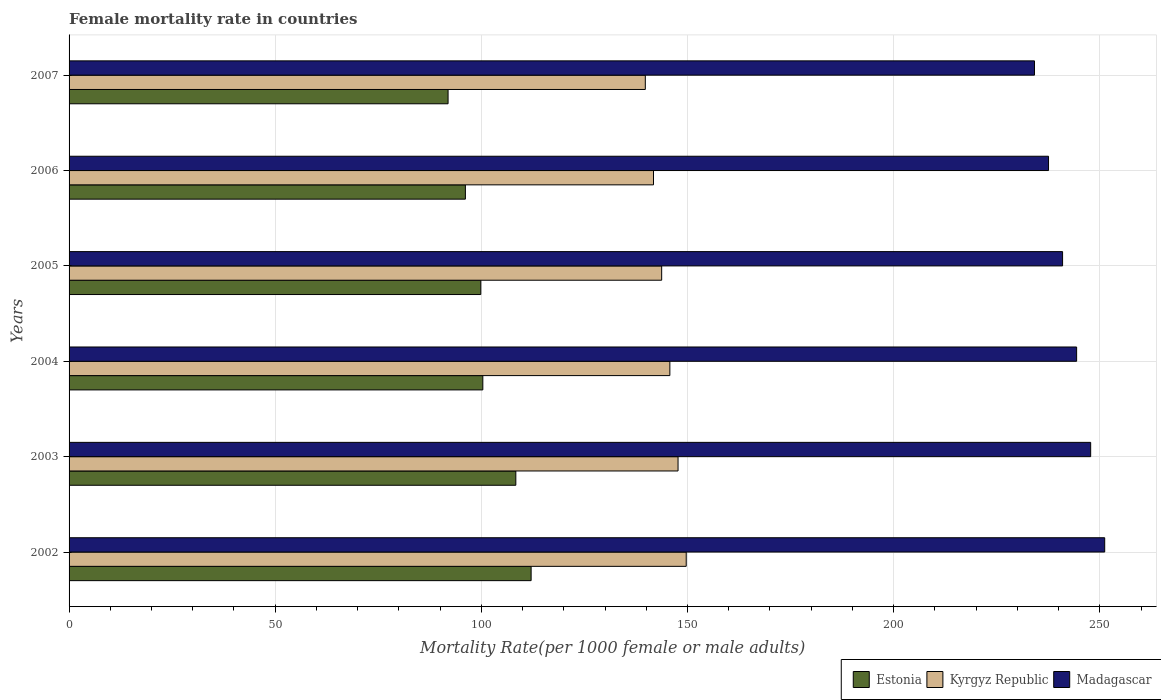Are the number of bars on each tick of the Y-axis equal?
Give a very brief answer. Yes. How many bars are there on the 5th tick from the bottom?
Offer a terse response. 3. What is the label of the 3rd group of bars from the top?
Your answer should be very brief. 2005. In how many cases, is the number of bars for a given year not equal to the number of legend labels?
Offer a terse response. 0. What is the female mortality rate in Kyrgyz Republic in 2005?
Give a very brief answer. 143.73. Across all years, what is the maximum female mortality rate in Estonia?
Offer a terse response. 112.07. Across all years, what is the minimum female mortality rate in Madagascar?
Make the answer very short. 234.15. In which year was the female mortality rate in Madagascar maximum?
Provide a succinct answer. 2002. What is the total female mortality rate in Estonia in the graph?
Keep it short and to the point. 608.68. What is the difference between the female mortality rate in Madagascar in 2002 and that in 2006?
Give a very brief answer. 13.63. What is the difference between the female mortality rate in Estonia in 2005 and the female mortality rate in Kyrgyz Republic in 2003?
Offer a terse response. -47.84. What is the average female mortality rate in Estonia per year?
Offer a very short reply. 101.45. In the year 2002, what is the difference between the female mortality rate in Estonia and female mortality rate in Kyrgyz Republic?
Your answer should be compact. -37.62. What is the ratio of the female mortality rate in Madagascar in 2002 to that in 2006?
Provide a succinct answer. 1.06. Is the female mortality rate in Madagascar in 2003 less than that in 2004?
Provide a short and direct response. No. What is the difference between the highest and the second highest female mortality rate in Estonia?
Provide a short and direct response. 3.71. What is the difference between the highest and the lowest female mortality rate in Kyrgyz Republic?
Your answer should be very brief. 9.92. Is the sum of the female mortality rate in Kyrgyz Republic in 2002 and 2007 greater than the maximum female mortality rate in Estonia across all years?
Provide a succinct answer. Yes. What does the 3rd bar from the top in 2002 represents?
Your answer should be compact. Estonia. What does the 3rd bar from the bottom in 2006 represents?
Give a very brief answer. Madagascar. Is it the case that in every year, the sum of the female mortality rate in Kyrgyz Republic and female mortality rate in Estonia is greater than the female mortality rate in Madagascar?
Provide a short and direct response. No. How many bars are there?
Give a very brief answer. 18. Are the values on the major ticks of X-axis written in scientific E-notation?
Provide a short and direct response. No. Does the graph contain any zero values?
Your answer should be compact. No. Does the graph contain grids?
Your answer should be compact. Yes. How are the legend labels stacked?
Provide a short and direct response. Horizontal. What is the title of the graph?
Offer a terse response. Female mortality rate in countries. Does "Albania" appear as one of the legend labels in the graph?
Your response must be concise. No. What is the label or title of the X-axis?
Provide a succinct answer. Mortality Rate(per 1000 female or male adults). What is the Mortality Rate(per 1000 female or male adults) of Estonia in 2002?
Offer a very short reply. 112.07. What is the Mortality Rate(per 1000 female or male adults) of Kyrgyz Republic in 2002?
Your response must be concise. 149.68. What is the Mortality Rate(per 1000 female or male adults) in Madagascar in 2002?
Your response must be concise. 251.18. What is the Mortality Rate(per 1000 female or male adults) in Estonia in 2003?
Provide a succinct answer. 108.36. What is the Mortality Rate(per 1000 female or male adults) of Kyrgyz Republic in 2003?
Provide a succinct answer. 147.7. What is the Mortality Rate(per 1000 female or male adults) of Madagascar in 2003?
Provide a succinct answer. 247.78. What is the Mortality Rate(per 1000 female or male adults) of Estonia in 2004?
Your answer should be compact. 100.35. What is the Mortality Rate(per 1000 female or male adults) in Kyrgyz Republic in 2004?
Provide a succinct answer. 145.72. What is the Mortality Rate(per 1000 female or male adults) of Madagascar in 2004?
Provide a succinct answer. 244.37. What is the Mortality Rate(per 1000 female or male adults) in Estonia in 2005?
Your answer should be very brief. 99.86. What is the Mortality Rate(per 1000 female or male adults) of Kyrgyz Republic in 2005?
Ensure brevity in your answer.  143.73. What is the Mortality Rate(per 1000 female or male adults) of Madagascar in 2005?
Make the answer very short. 240.96. What is the Mortality Rate(per 1000 female or male adults) in Estonia in 2006?
Give a very brief answer. 96.12. What is the Mortality Rate(per 1000 female or male adults) of Kyrgyz Republic in 2006?
Your response must be concise. 141.75. What is the Mortality Rate(per 1000 female or male adults) of Madagascar in 2006?
Keep it short and to the point. 237.56. What is the Mortality Rate(per 1000 female or male adults) in Estonia in 2007?
Provide a succinct answer. 91.93. What is the Mortality Rate(per 1000 female or male adults) in Kyrgyz Republic in 2007?
Make the answer very short. 139.76. What is the Mortality Rate(per 1000 female or male adults) of Madagascar in 2007?
Your response must be concise. 234.15. Across all years, what is the maximum Mortality Rate(per 1000 female or male adults) of Estonia?
Provide a succinct answer. 112.07. Across all years, what is the maximum Mortality Rate(per 1000 female or male adults) of Kyrgyz Republic?
Ensure brevity in your answer.  149.68. Across all years, what is the maximum Mortality Rate(per 1000 female or male adults) in Madagascar?
Offer a terse response. 251.18. Across all years, what is the minimum Mortality Rate(per 1000 female or male adults) in Estonia?
Provide a short and direct response. 91.93. Across all years, what is the minimum Mortality Rate(per 1000 female or male adults) in Kyrgyz Republic?
Ensure brevity in your answer.  139.76. Across all years, what is the minimum Mortality Rate(per 1000 female or male adults) of Madagascar?
Offer a terse response. 234.15. What is the total Mortality Rate(per 1000 female or male adults) in Estonia in the graph?
Ensure brevity in your answer.  608.68. What is the total Mortality Rate(per 1000 female or male adults) in Kyrgyz Republic in the graph?
Provide a succinct answer. 868.34. What is the total Mortality Rate(per 1000 female or male adults) of Madagascar in the graph?
Your response must be concise. 1456.01. What is the difference between the Mortality Rate(per 1000 female or male adults) of Estonia in 2002 and that in 2003?
Make the answer very short. 3.71. What is the difference between the Mortality Rate(per 1000 female or male adults) in Kyrgyz Republic in 2002 and that in 2003?
Ensure brevity in your answer.  1.98. What is the difference between the Mortality Rate(per 1000 female or male adults) of Madagascar in 2002 and that in 2003?
Offer a terse response. 3.41. What is the difference between the Mortality Rate(per 1000 female or male adults) in Estonia in 2002 and that in 2004?
Offer a very short reply. 11.71. What is the difference between the Mortality Rate(per 1000 female or male adults) in Kyrgyz Republic in 2002 and that in 2004?
Keep it short and to the point. 3.97. What is the difference between the Mortality Rate(per 1000 female or male adults) of Madagascar in 2002 and that in 2004?
Offer a terse response. 6.81. What is the difference between the Mortality Rate(per 1000 female or male adults) of Estonia in 2002 and that in 2005?
Your answer should be compact. 12.21. What is the difference between the Mortality Rate(per 1000 female or male adults) in Kyrgyz Republic in 2002 and that in 2005?
Your answer should be compact. 5.95. What is the difference between the Mortality Rate(per 1000 female or male adults) of Madagascar in 2002 and that in 2005?
Offer a very short reply. 10.22. What is the difference between the Mortality Rate(per 1000 female or male adults) of Estonia in 2002 and that in 2006?
Ensure brevity in your answer.  15.95. What is the difference between the Mortality Rate(per 1000 female or male adults) in Kyrgyz Republic in 2002 and that in 2006?
Your answer should be compact. 7.94. What is the difference between the Mortality Rate(per 1000 female or male adults) in Madagascar in 2002 and that in 2006?
Your response must be concise. 13.63. What is the difference between the Mortality Rate(per 1000 female or male adults) of Estonia in 2002 and that in 2007?
Offer a terse response. 20.14. What is the difference between the Mortality Rate(per 1000 female or male adults) in Kyrgyz Republic in 2002 and that in 2007?
Ensure brevity in your answer.  9.92. What is the difference between the Mortality Rate(per 1000 female or male adults) in Madagascar in 2002 and that in 2007?
Your answer should be very brief. 17.03. What is the difference between the Mortality Rate(per 1000 female or male adults) in Estonia in 2003 and that in 2004?
Provide a succinct answer. 8. What is the difference between the Mortality Rate(per 1000 female or male adults) in Kyrgyz Republic in 2003 and that in 2004?
Make the answer very short. 1.98. What is the difference between the Mortality Rate(per 1000 female or male adults) of Madagascar in 2003 and that in 2004?
Ensure brevity in your answer.  3.41. What is the difference between the Mortality Rate(per 1000 female or male adults) of Estonia in 2003 and that in 2005?
Make the answer very short. 8.49. What is the difference between the Mortality Rate(per 1000 female or male adults) in Kyrgyz Republic in 2003 and that in 2005?
Your answer should be compact. 3.97. What is the difference between the Mortality Rate(per 1000 female or male adults) of Madagascar in 2003 and that in 2005?
Your answer should be very brief. 6.81. What is the difference between the Mortality Rate(per 1000 female or male adults) in Estonia in 2003 and that in 2006?
Make the answer very short. 12.23. What is the difference between the Mortality Rate(per 1000 female or male adults) in Kyrgyz Republic in 2003 and that in 2006?
Offer a terse response. 5.95. What is the difference between the Mortality Rate(per 1000 female or male adults) of Madagascar in 2003 and that in 2006?
Offer a very short reply. 10.22. What is the difference between the Mortality Rate(per 1000 female or male adults) of Estonia in 2003 and that in 2007?
Your answer should be very brief. 16.43. What is the difference between the Mortality Rate(per 1000 female or male adults) in Kyrgyz Republic in 2003 and that in 2007?
Keep it short and to the point. 7.94. What is the difference between the Mortality Rate(per 1000 female or male adults) of Madagascar in 2003 and that in 2007?
Keep it short and to the point. 13.63. What is the difference between the Mortality Rate(per 1000 female or male adults) in Estonia in 2004 and that in 2005?
Keep it short and to the point. 0.49. What is the difference between the Mortality Rate(per 1000 female or male adults) in Kyrgyz Republic in 2004 and that in 2005?
Your answer should be compact. 1.98. What is the difference between the Mortality Rate(per 1000 female or male adults) of Madagascar in 2004 and that in 2005?
Offer a terse response. 3.41. What is the difference between the Mortality Rate(per 1000 female or male adults) of Estonia in 2004 and that in 2006?
Make the answer very short. 4.23. What is the difference between the Mortality Rate(per 1000 female or male adults) in Kyrgyz Republic in 2004 and that in 2006?
Make the answer very short. 3.97. What is the difference between the Mortality Rate(per 1000 female or male adults) in Madagascar in 2004 and that in 2006?
Keep it short and to the point. 6.81. What is the difference between the Mortality Rate(per 1000 female or male adults) in Estonia in 2004 and that in 2007?
Your answer should be very brief. 8.43. What is the difference between the Mortality Rate(per 1000 female or male adults) in Kyrgyz Republic in 2004 and that in 2007?
Make the answer very short. 5.95. What is the difference between the Mortality Rate(per 1000 female or male adults) in Madagascar in 2004 and that in 2007?
Provide a short and direct response. 10.22. What is the difference between the Mortality Rate(per 1000 female or male adults) in Estonia in 2005 and that in 2006?
Offer a terse response. 3.74. What is the difference between the Mortality Rate(per 1000 female or male adults) of Kyrgyz Republic in 2005 and that in 2006?
Offer a very short reply. 1.98. What is the difference between the Mortality Rate(per 1000 female or male adults) of Madagascar in 2005 and that in 2006?
Provide a short and direct response. 3.41. What is the difference between the Mortality Rate(per 1000 female or male adults) of Estonia in 2005 and that in 2007?
Give a very brief answer. 7.93. What is the difference between the Mortality Rate(per 1000 female or male adults) of Kyrgyz Republic in 2005 and that in 2007?
Your answer should be very brief. 3.97. What is the difference between the Mortality Rate(per 1000 female or male adults) of Madagascar in 2005 and that in 2007?
Provide a succinct answer. 6.81. What is the difference between the Mortality Rate(per 1000 female or male adults) in Estonia in 2006 and that in 2007?
Make the answer very short. 4.2. What is the difference between the Mortality Rate(per 1000 female or male adults) of Kyrgyz Republic in 2006 and that in 2007?
Your response must be concise. 1.98. What is the difference between the Mortality Rate(per 1000 female or male adults) in Madagascar in 2006 and that in 2007?
Ensure brevity in your answer.  3.41. What is the difference between the Mortality Rate(per 1000 female or male adults) of Estonia in 2002 and the Mortality Rate(per 1000 female or male adults) of Kyrgyz Republic in 2003?
Ensure brevity in your answer.  -35.63. What is the difference between the Mortality Rate(per 1000 female or male adults) in Estonia in 2002 and the Mortality Rate(per 1000 female or male adults) in Madagascar in 2003?
Ensure brevity in your answer.  -135.71. What is the difference between the Mortality Rate(per 1000 female or male adults) of Kyrgyz Republic in 2002 and the Mortality Rate(per 1000 female or male adults) of Madagascar in 2003?
Keep it short and to the point. -98.09. What is the difference between the Mortality Rate(per 1000 female or male adults) in Estonia in 2002 and the Mortality Rate(per 1000 female or male adults) in Kyrgyz Republic in 2004?
Your answer should be compact. -33.65. What is the difference between the Mortality Rate(per 1000 female or male adults) in Estonia in 2002 and the Mortality Rate(per 1000 female or male adults) in Madagascar in 2004?
Make the answer very short. -132.3. What is the difference between the Mortality Rate(per 1000 female or male adults) in Kyrgyz Republic in 2002 and the Mortality Rate(per 1000 female or male adults) in Madagascar in 2004?
Provide a succinct answer. -94.69. What is the difference between the Mortality Rate(per 1000 female or male adults) in Estonia in 2002 and the Mortality Rate(per 1000 female or male adults) in Kyrgyz Republic in 2005?
Your answer should be compact. -31.66. What is the difference between the Mortality Rate(per 1000 female or male adults) of Estonia in 2002 and the Mortality Rate(per 1000 female or male adults) of Madagascar in 2005?
Provide a succinct answer. -128.9. What is the difference between the Mortality Rate(per 1000 female or male adults) in Kyrgyz Republic in 2002 and the Mortality Rate(per 1000 female or male adults) in Madagascar in 2005?
Make the answer very short. -91.28. What is the difference between the Mortality Rate(per 1000 female or male adults) in Estonia in 2002 and the Mortality Rate(per 1000 female or male adults) in Kyrgyz Republic in 2006?
Offer a terse response. -29.68. What is the difference between the Mortality Rate(per 1000 female or male adults) of Estonia in 2002 and the Mortality Rate(per 1000 female or male adults) of Madagascar in 2006?
Your response must be concise. -125.49. What is the difference between the Mortality Rate(per 1000 female or male adults) in Kyrgyz Republic in 2002 and the Mortality Rate(per 1000 female or male adults) in Madagascar in 2006?
Make the answer very short. -87.87. What is the difference between the Mortality Rate(per 1000 female or male adults) of Estonia in 2002 and the Mortality Rate(per 1000 female or male adults) of Kyrgyz Republic in 2007?
Offer a terse response. -27.7. What is the difference between the Mortality Rate(per 1000 female or male adults) in Estonia in 2002 and the Mortality Rate(per 1000 female or male adults) in Madagascar in 2007?
Give a very brief answer. -122.08. What is the difference between the Mortality Rate(per 1000 female or male adults) of Kyrgyz Republic in 2002 and the Mortality Rate(per 1000 female or male adults) of Madagascar in 2007?
Keep it short and to the point. -84.47. What is the difference between the Mortality Rate(per 1000 female or male adults) of Estonia in 2003 and the Mortality Rate(per 1000 female or male adults) of Kyrgyz Republic in 2004?
Offer a terse response. -37.36. What is the difference between the Mortality Rate(per 1000 female or male adults) of Estonia in 2003 and the Mortality Rate(per 1000 female or male adults) of Madagascar in 2004?
Your answer should be compact. -136.02. What is the difference between the Mortality Rate(per 1000 female or male adults) in Kyrgyz Republic in 2003 and the Mortality Rate(per 1000 female or male adults) in Madagascar in 2004?
Make the answer very short. -96.67. What is the difference between the Mortality Rate(per 1000 female or male adults) of Estonia in 2003 and the Mortality Rate(per 1000 female or male adults) of Kyrgyz Republic in 2005?
Provide a short and direct response. -35.38. What is the difference between the Mortality Rate(per 1000 female or male adults) in Estonia in 2003 and the Mortality Rate(per 1000 female or male adults) in Madagascar in 2005?
Your response must be concise. -132.61. What is the difference between the Mortality Rate(per 1000 female or male adults) in Kyrgyz Republic in 2003 and the Mortality Rate(per 1000 female or male adults) in Madagascar in 2005?
Offer a very short reply. -93.26. What is the difference between the Mortality Rate(per 1000 female or male adults) of Estonia in 2003 and the Mortality Rate(per 1000 female or male adults) of Kyrgyz Republic in 2006?
Your answer should be very brief. -33.39. What is the difference between the Mortality Rate(per 1000 female or male adults) in Estonia in 2003 and the Mortality Rate(per 1000 female or male adults) in Madagascar in 2006?
Your answer should be very brief. -129.2. What is the difference between the Mortality Rate(per 1000 female or male adults) in Kyrgyz Republic in 2003 and the Mortality Rate(per 1000 female or male adults) in Madagascar in 2006?
Give a very brief answer. -89.86. What is the difference between the Mortality Rate(per 1000 female or male adults) in Estonia in 2003 and the Mortality Rate(per 1000 female or male adults) in Kyrgyz Republic in 2007?
Your answer should be very brief. -31.41. What is the difference between the Mortality Rate(per 1000 female or male adults) of Estonia in 2003 and the Mortality Rate(per 1000 female or male adults) of Madagascar in 2007?
Your answer should be compact. -125.8. What is the difference between the Mortality Rate(per 1000 female or male adults) in Kyrgyz Republic in 2003 and the Mortality Rate(per 1000 female or male adults) in Madagascar in 2007?
Give a very brief answer. -86.45. What is the difference between the Mortality Rate(per 1000 female or male adults) of Estonia in 2004 and the Mortality Rate(per 1000 female or male adults) of Kyrgyz Republic in 2005?
Give a very brief answer. -43.38. What is the difference between the Mortality Rate(per 1000 female or male adults) of Estonia in 2004 and the Mortality Rate(per 1000 female or male adults) of Madagascar in 2005?
Your answer should be very brief. -140.61. What is the difference between the Mortality Rate(per 1000 female or male adults) of Kyrgyz Republic in 2004 and the Mortality Rate(per 1000 female or male adults) of Madagascar in 2005?
Provide a short and direct response. -95.25. What is the difference between the Mortality Rate(per 1000 female or male adults) of Estonia in 2004 and the Mortality Rate(per 1000 female or male adults) of Kyrgyz Republic in 2006?
Make the answer very short. -41.39. What is the difference between the Mortality Rate(per 1000 female or male adults) in Estonia in 2004 and the Mortality Rate(per 1000 female or male adults) in Madagascar in 2006?
Provide a short and direct response. -137.21. What is the difference between the Mortality Rate(per 1000 female or male adults) in Kyrgyz Republic in 2004 and the Mortality Rate(per 1000 female or male adults) in Madagascar in 2006?
Your answer should be very brief. -91.84. What is the difference between the Mortality Rate(per 1000 female or male adults) of Estonia in 2004 and the Mortality Rate(per 1000 female or male adults) of Kyrgyz Republic in 2007?
Ensure brevity in your answer.  -39.41. What is the difference between the Mortality Rate(per 1000 female or male adults) in Estonia in 2004 and the Mortality Rate(per 1000 female or male adults) in Madagascar in 2007?
Give a very brief answer. -133.8. What is the difference between the Mortality Rate(per 1000 female or male adults) of Kyrgyz Republic in 2004 and the Mortality Rate(per 1000 female or male adults) of Madagascar in 2007?
Your answer should be compact. -88.44. What is the difference between the Mortality Rate(per 1000 female or male adults) in Estonia in 2005 and the Mortality Rate(per 1000 female or male adults) in Kyrgyz Republic in 2006?
Keep it short and to the point. -41.89. What is the difference between the Mortality Rate(per 1000 female or male adults) of Estonia in 2005 and the Mortality Rate(per 1000 female or male adults) of Madagascar in 2006?
Your answer should be compact. -137.7. What is the difference between the Mortality Rate(per 1000 female or male adults) of Kyrgyz Republic in 2005 and the Mortality Rate(per 1000 female or male adults) of Madagascar in 2006?
Give a very brief answer. -93.83. What is the difference between the Mortality Rate(per 1000 female or male adults) of Estonia in 2005 and the Mortality Rate(per 1000 female or male adults) of Kyrgyz Republic in 2007?
Your answer should be very brief. -39.9. What is the difference between the Mortality Rate(per 1000 female or male adults) of Estonia in 2005 and the Mortality Rate(per 1000 female or male adults) of Madagascar in 2007?
Provide a succinct answer. -134.29. What is the difference between the Mortality Rate(per 1000 female or male adults) of Kyrgyz Republic in 2005 and the Mortality Rate(per 1000 female or male adults) of Madagascar in 2007?
Provide a short and direct response. -90.42. What is the difference between the Mortality Rate(per 1000 female or male adults) in Estonia in 2006 and the Mortality Rate(per 1000 female or male adults) in Kyrgyz Republic in 2007?
Your answer should be compact. -43.64. What is the difference between the Mortality Rate(per 1000 female or male adults) in Estonia in 2006 and the Mortality Rate(per 1000 female or male adults) in Madagascar in 2007?
Make the answer very short. -138.03. What is the difference between the Mortality Rate(per 1000 female or male adults) in Kyrgyz Republic in 2006 and the Mortality Rate(per 1000 female or male adults) in Madagascar in 2007?
Make the answer very short. -92.4. What is the average Mortality Rate(per 1000 female or male adults) of Estonia per year?
Provide a short and direct response. 101.45. What is the average Mortality Rate(per 1000 female or male adults) in Kyrgyz Republic per year?
Offer a terse response. 144.72. What is the average Mortality Rate(per 1000 female or male adults) of Madagascar per year?
Provide a succinct answer. 242.67. In the year 2002, what is the difference between the Mortality Rate(per 1000 female or male adults) of Estonia and Mortality Rate(per 1000 female or male adults) of Kyrgyz Republic?
Offer a very short reply. -37.62. In the year 2002, what is the difference between the Mortality Rate(per 1000 female or male adults) of Estonia and Mortality Rate(per 1000 female or male adults) of Madagascar?
Your answer should be compact. -139.12. In the year 2002, what is the difference between the Mortality Rate(per 1000 female or male adults) of Kyrgyz Republic and Mortality Rate(per 1000 female or male adults) of Madagascar?
Your answer should be very brief. -101.5. In the year 2003, what is the difference between the Mortality Rate(per 1000 female or male adults) in Estonia and Mortality Rate(per 1000 female or male adults) in Kyrgyz Republic?
Offer a terse response. -39.34. In the year 2003, what is the difference between the Mortality Rate(per 1000 female or male adults) of Estonia and Mortality Rate(per 1000 female or male adults) of Madagascar?
Offer a very short reply. -139.42. In the year 2003, what is the difference between the Mortality Rate(per 1000 female or male adults) in Kyrgyz Republic and Mortality Rate(per 1000 female or male adults) in Madagascar?
Give a very brief answer. -100.08. In the year 2004, what is the difference between the Mortality Rate(per 1000 female or male adults) of Estonia and Mortality Rate(per 1000 female or male adults) of Kyrgyz Republic?
Provide a succinct answer. -45.36. In the year 2004, what is the difference between the Mortality Rate(per 1000 female or male adults) in Estonia and Mortality Rate(per 1000 female or male adults) in Madagascar?
Keep it short and to the point. -144.02. In the year 2004, what is the difference between the Mortality Rate(per 1000 female or male adults) of Kyrgyz Republic and Mortality Rate(per 1000 female or male adults) of Madagascar?
Ensure brevity in your answer.  -98.66. In the year 2005, what is the difference between the Mortality Rate(per 1000 female or male adults) in Estonia and Mortality Rate(per 1000 female or male adults) in Kyrgyz Republic?
Make the answer very short. -43.87. In the year 2005, what is the difference between the Mortality Rate(per 1000 female or male adults) in Estonia and Mortality Rate(per 1000 female or male adults) in Madagascar?
Keep it short and to the point. -141.1. In the year 2005, what is the difference between the Mortality Rate(per 1000 female or male adults) in Kyrgyz Republic and Mortality Rate(per 1000 female or male adults) in Madagascar?
Give a very brief answer. -97.23. In the year 2006, what is the difference between the Mortality Rate(per 1000 female or male adults) of Estonia and Mortality Rate(per 1000 female or male adults) of Kyrgyz Republic?
Make the answer very short. -45.62. In the year 2006, what is the difference between the Mortality Rate(per 1000 female or male adults) in Estonia and Mortality Rate(per 1000 female or male adults) in Madagascar?
Your answer should be very brief. -141.44. In the year 2006, what is the difference between the Mortality Rate(per 1000 female or male adults) in Kyrgyz Republic and Mortality Rate(per 1000 female or male adults) in Madagascar?
Keep it short and to the point. -95.81. In the year 2007, what is the difference between the Mortality Rate(per 1000 female or male adults) of Estonia and Mortality Rate(per 1000 female or male adults) of Kyrgyz Republic?
Your response must be concise. -47.84. In the year 2007, what is the difference between the Mortality Rate(per 1000 female or male adults) of Estonia and Mortality Rate(per 1000 female or male adults) of Madagascar?
Your answer should be very brief. -142.22. In the year 2007, what is the difference between the Mortality Rate(per 1000 female or male adults) of Kyrgyz Republic and Mortality Rate(per 1000 female or male adults) of Madagascar?
Offer a very short reply. -94.39. What is the ratio of the Mortality Rate(per 1000 female or male adults) in Estonia in 2002 to that in 2003?
Provide a succinct answer. 1.03. What is the ratio of the Mortality Rate(per 1000 female or male adults) in Kyrgyz Republic in 2002 to that in 2003?
Offer a very short reply. 1.01. What is the ratio of the Mortality Rate(per 1000 female or male adults) of Madagascar in 2002 to that in 2003?
Keep it short and to the point. 1.01. What is the ratio of the Mortality Rate(per 1000 female or male adults) of Estonia in 2002 to that in 2004?
Provide a short and direct response. 1.12. What is the ratio of the Mortality Rate(per 1000 female or male adults) in Kyrgyz Republic in 2002 to that in 2004?
Offer a terse response. 1.03. What is the ratio of the Mortality Rate(per 1000 female or male adults) of Madagascar in 2002 to that in 2004?
Provide a short and direct response. 1.03. What is the ratio of the Mortality Rate(per 1000 female or male adults) in Estonia in 2002 to that in 2005?
Make the answer very short. 1.12. What is the ratio of the Mortality Rate(per 1000 female or male adults) of Kyrgyz Republic in 2002 to that in 2005?
Keep it short and to the point. 1.04. What is the ratio of the Mortality Rate(per 1000 female or male adults) in Madagascar in 2002 to that in 2005?
Ensure brevity in your answer.  1.04. What is the ratio of the Mortality Rate(per 1000 female or male adults) of Estonia in 2002 to that in 2006?
Offer a very short reply. 1.17. What is the ratio of the Mortality Rate(per 1000 female or male adults) in Kyrgyz Republic in 2002 to that in 2006?
Provide a short and direct response. 1.06. What is the ratio of the Mortality Rate(per 1000 female or male adults) of Madagascar in 2002 to that in 2006?
Ensure brevity in your answer.  1.06. What is the ratio of the Mortality Rate(per 1000 female or male adults) of Estonia in 2002 to that in 2007?
Provide a short and direct response. 1.22. What is the ratio of the Mortality Rate(per 1000 female or male adults) in Kyrgyz Republic in 2002 to that in 2007?
Offer a terse response. 1.07. What is the ratio of the Mortality Rate(per 1000 female or male adults) in Madagascar in 2002 to that in 2007?
Offer a terse response. 1.07. What is the ratio of the Mortality Rate(per 1000 female or male adults) of Estonia in 2003 to that in 2004?
Provide a short and direct response. 1.08. What is the ratio of the Mortality Rate(per 1000 female or male adults) in Kyrgyz Republic in 2003 to that in 2004?
Provide a short and direct response. 1.01. What is the ratio of the Mortality Rate(per 1000 female or male adults) of Madagascar in 2003 to that in 2004?
Offer a very short reply. 1.01. What is the ratio of the Mortality Rate(per 1000 female or male adults) in Estonia in 2003 to that in 2005?
Keep it short and to the point. 1.09. What is the ratio of the Mortality Rate(per 1000 female or male adults) of Kyrgyz Republic in 2003 to that in 2005?
Your response must be concise. 1.03. What is the ratio of the Mortality Rate(per 1000 female or male adults) in Madagascar in 2003 to that in 2005?
Offer a very short reply. 1.03. What is the ratio of the Mortality Rate(per 1000 female or male adults) of Estonia in 2003 to that in 2006?
Your answer should be compact. 1.13. What is the ratio of the Mortality Rate(per 1000 female or male adults) of Kyrgyz Republic in 2003 to that in 2006?
Offer a terse response. 1.04. What is the ratio of the Mortality Rate(per 1000 female or male adults) of Madagascar in 2003 to that in 2006?
Keep it short and to the point. 1.04. What is the ratio of the Mortality Rate(per 1000 female or male adults) in Estonia in 2003 to that in 2007?
Keep it short and to the point. 1.18. What is the ratio of the Mortality Rate(per 1000 female or male adults) of Kyrgyz Republic in 2003 to that in 2007?
Your answer should be very brief. 1.06. What is the ratio of the Mortality Rate(per 1000 female or male adults) in Madagascar in 2003 to that in 2007?
Your answer should be compact. 1.06. What is the ratio of the Mortality Rate(per 1000 female or male adults) in Kyrgyz Republic in 2004 to that in 2005?
Give a very brief answer. 1.01. What is the ratio of the Mortality Rate(per 1000 female or male adults) in Madagascar in 2004 to that in 2005?
Keep it short and to the point. 1.01. What is the ratio of the Mortality Rate(per 1000 female or male adults) of Estonia in 2004 to that in 2006?
Your answer should be compact. 1.04. What is the ratio of the Mortality Rate(per 1000 female or male adults) in Kyrgyz Republic in 2004 to that in 2006?
Provide a short and direct response. 1.03. What is the ratio of the Mortality Rate(per 1000 female or male adults) of Madagascar in 2004 to that in 2006?
Give a very brief answer. 1.03. What is the ratio of the Mortality Rate(per 1000 female or male adults) of Estonia in 2004 to that in 2007?
Keep it short and to the point. 1.09. What is the ratio of the Mortality Rate(per 1000 female or male adults) of Kyrgyz Republic in 2004 to that in 2007?
Provide a short and direct response. 1.04. What is the ratio of the Mortality Rate(per 1000 female or male adults) in Madagascar in 2004 to that in 2007?
Your answer should be very brief. 1.04. What is the ratio of the Mortality Rate(per 1000 female or male adults) in Estonia in 2005 to that in 2006?
Provide a short and direct response. 1.04. What is the ratio of the Mortality Rate(per 1000 female or male adults) in Madagascar in 2005 to that in 2006?
Provide a short and direct response. 1.01. What is the ratio of the Mortality Rate(per 1000 female or male adults) in Estonia in 2005 to that in 2007?
Your response must be concise. 1.09. What is the ratio of the Mortality Rate(per 1000 female or male adults) in Kyrgyz Republic in 2005 to that in 2007?
Provide a short and direct response. 1.03. What is the ratio of the Mortality Rate(per 1000 female or male adults) in Madagascar in 2005 to that in 2007?
Offer a very short reply. 1.03. What is the ratio of the Mortality Rate(per 1000 female or male adults) of Estonia in 2006 to that in 2007?
Offer a very short reply. 1.05. What is the ratio of the Mortality Rate(per 1000 female or male adults) in Kyrgyz Republic in 2006 to that in 2007?
Ensure brevity in your answer.  1.01. What is the ratio of the Mortality Rate(per 1000 female or male adults) in Madagascar in 2006 to that in 2007?
Provide a short and direct response. 1.01. What is the difference between the highest and the second highest Mortality Rate(per 1000 female or male adults) in Estonia?
Give a very brief answer. 3.71. What is the difference between the highest and the second highest Mortality Rate(per 1000 female or male adults) in Kyrgyz Republic?
Provide a succinct answer. 1.98. What is the difference between the highest and the second highest Mortality Rate(per 1000 female or male adults) of Madagascar?
Keep it short and to the point. 3.41. What is the difference between the highest and the lowest Mortality Rate(per 1000 female or male adults) in Estonia?
Keep it short and to the point. 20.14. What is the difference between the highest and the lowest Mortality Rate(per 1000 female or male adults) of Kyrgyz Republic?
Give a very brief answer. 9.92. What is the difference between the highest and the lowest Mortality Rate(per 1000 female or male adults) of Madagascar?
Provide a succinct answer. 17.03. 